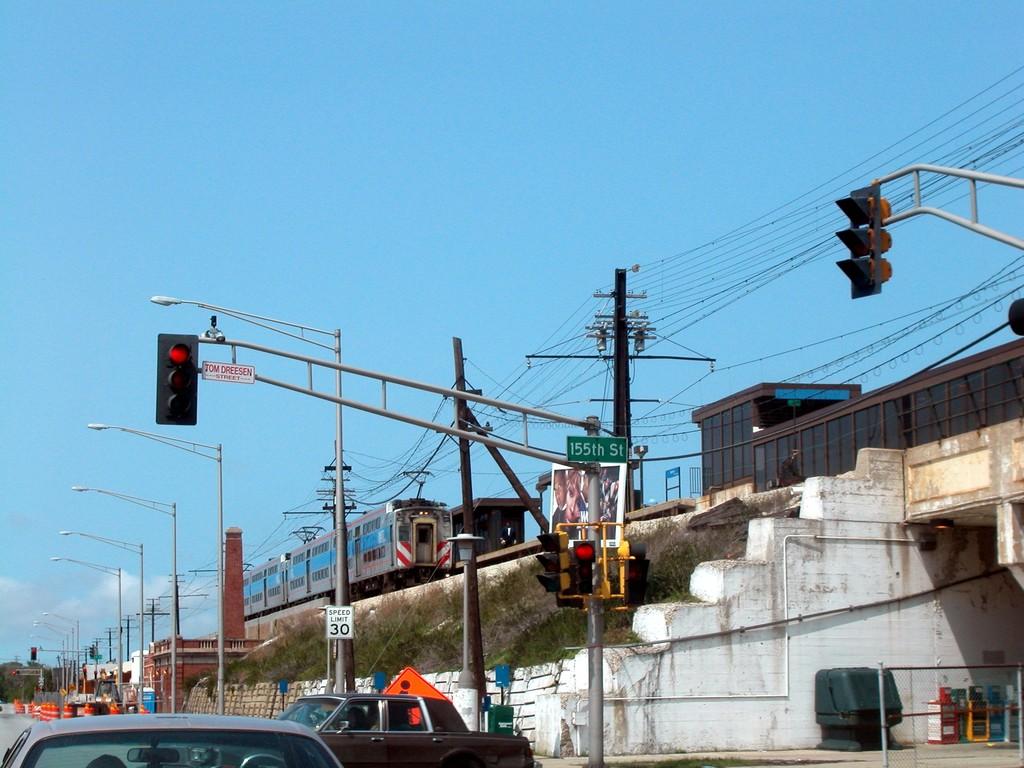What does the green street sign say?
Ensure brevity in your answer.  155th st. What is the name of the street?
Keep it short and to the point. 155th street. 